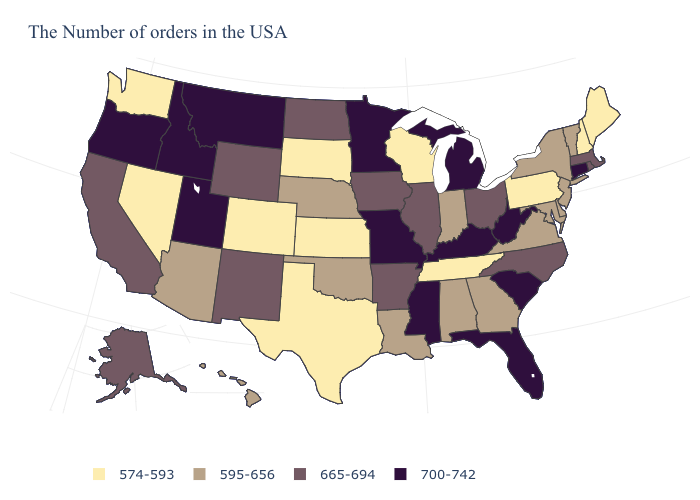Name the states that have a value in the range 700-742?
Be succinct. Connecticut, South Carolina, West Virginia, Florida, Michigan, Kentucky, Mississippi, Missouri, Minnesota, Utah, Montana, Idaho, Oregon. Among the states that border Washington , which have the highest value?
Be succinct. Idaho, Oregon. What is the value of Georgia?
Be succinct. 595-656. Name the states that have a value in the range 574-593?
Short answer required. Maine, New Hampshire, Pennsylvania, Tennessee, Wisconsin, Kansas, Texas, South Dakota, Colorado, Nevada, Washington. What is the value of Alaska?
Give a very brief answer. 665-694. Does Montana have the highest value in the West?
Keep it brief. Yes. What is the lowest value in states that border Idaho?
Keep it brief. 574-593. What is the value of Tennessee?
Short answer required. 574-593. Name the states that have a value in the range 574-593?
Write a very short answer. Maine, New Hampshire, Pennsylvania, Tennessee, Wisconsin, Kansas, Texas, South Dakota, Colorado, Nevada, Washington. Name the states that have a value in the range 665-694?
Give a very brief answer. Massachusetts, Rhode Island, North Carolina, Ohio, Illinois, Arkansas, Iowa, North Dakota, Wyoming, New Mexico, California, Alaska. Which states have the lowest value in the USA?
Give a very brief answer. Maine, New Hampshire, Pennsylvania, Tennessee, Wisconsin, Kansas, Texas, South Dakota, Colorado, Nevada, Washington. Which states have the lowest value in the South?
Write a very short answer. Tennessee, Texas. What is the value of North Dakota?
Be succinct. 665-694. Does Idaho have the highest value in the West?
Be succinct. Yes. What is the lowest value in the West?
Concise answer only. 574-593. 